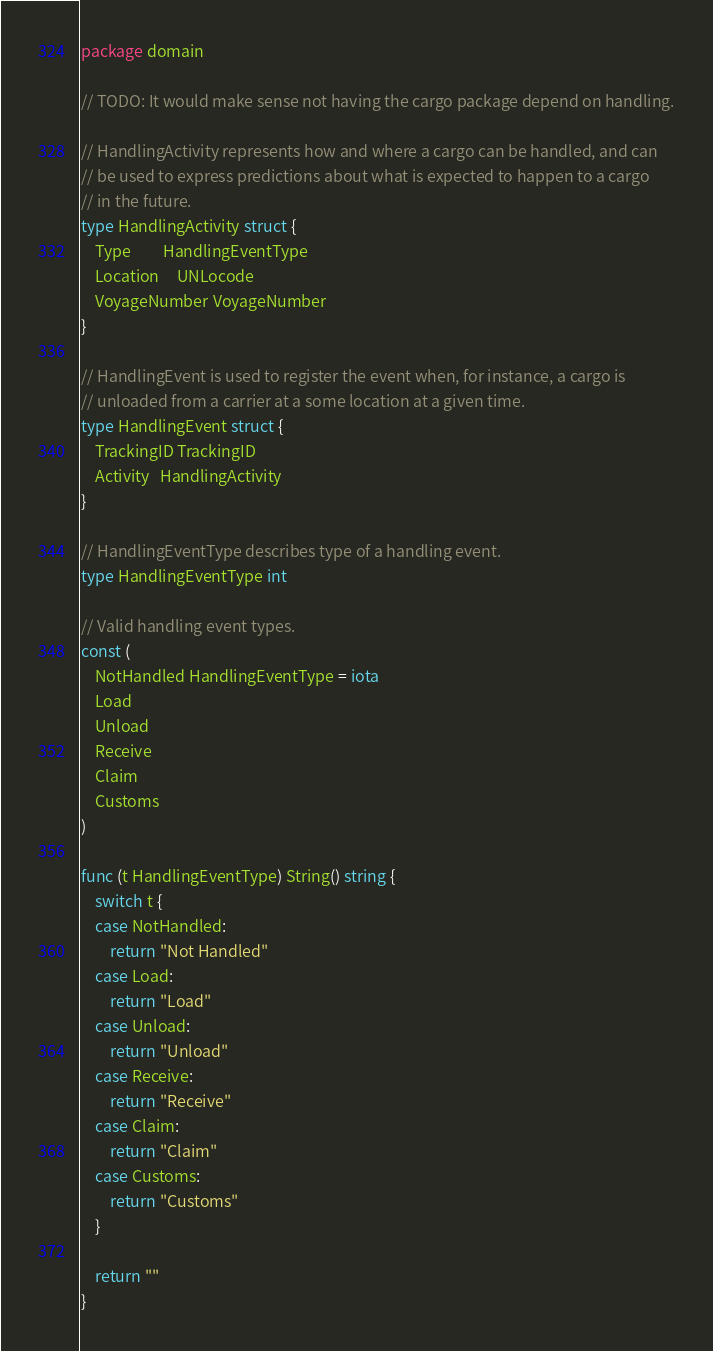<code> <loc_0><loc_0><loc_500><loc_500><_Go_>package domain

// TODO: It would make sense not having the cargo package depend on handling.

// HandlingActivity represents how and where a cargo can be handled, and can
// be used to express predictions about what is expected to happen to a cargo
// in the future.
type HandlingActivity struct {
	Type         HandlingEventType
	Location     UNLocode
	VoyageNumber VoyageNumber
}

// HandlingEvent is used to register the event when, for instance, a cargo is
// unloaded from a carrier at a some location at a given time.
type HandlingEvent struct {
	TrackingID TrackingID
	Activity   HandlingActivity
}

// HandlingEventType describes type of a handling event.
type HandlingEventType int

// Valid handling event types.
const (
	NotHandled HandlingEventType = iota
	Load
	Unload
	Receive
	Claim
	Customs
)

func (t HandlingEventType) String() string {
	switch t {
	case NotHandled:
		return "Not Handled"
	case Load:
		return "Load"
	case Unload:
		return "Unload"
	case Receive:
		return "Receive"
	case Claim:
		return "Claim"
	case Customs:
		return "Customs"
	}

	return ""
}
</code> 